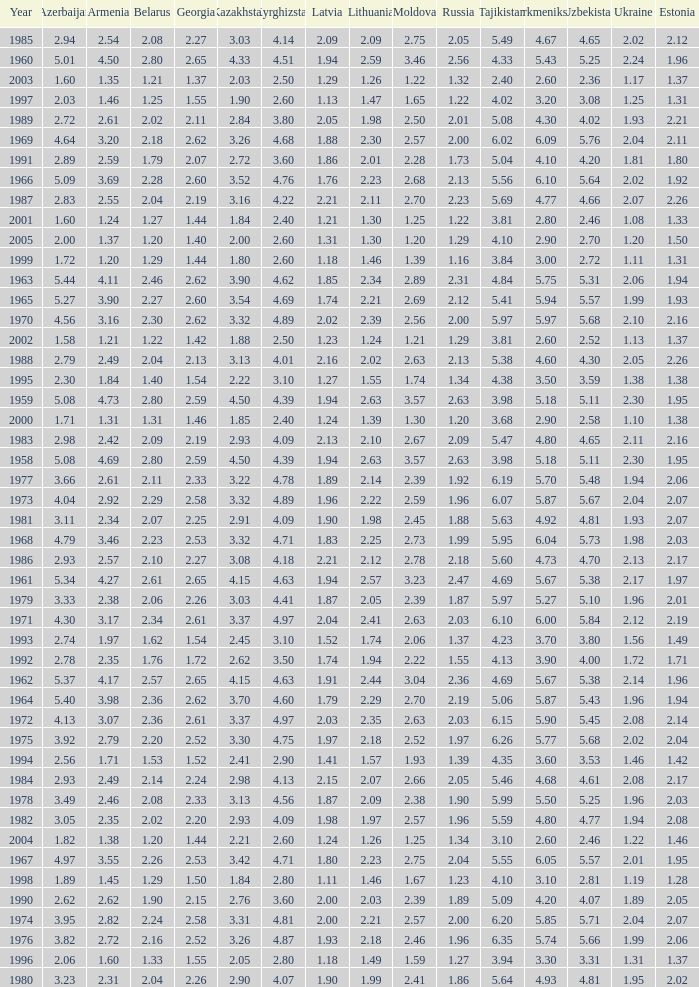Tell me the lowest kazakhstan for kyrghizstan of 4.62 and belarus less than 2.46 None. 